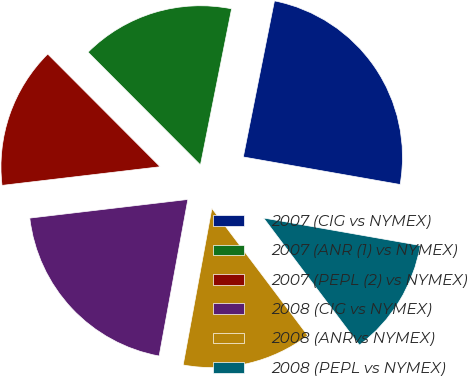Convert chart to OTSL. <chart><loc_0><loc_0><loc_500><loc_500><pie_chart><fcel>2007 (CIG vs NYMEX)<fcel>2007 (ANR (1) vs NYMEX)<fcel>2007 (PEPL (2) vs NYMEX)<fcel>2008 (CIG vs NYMEX)<fcel>2008 (ANRvs NYMEX)<fcel>2008 (PEPL vs NYMEX)<nl><fcel>24.63%<fcel>15.61%<fcel>14.39%<fcel>20.24%<fcel>13.17%<fcel>11.95%<nl></chart> 